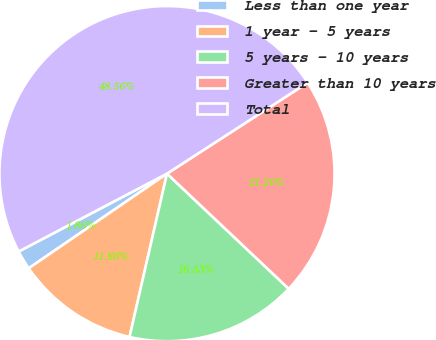Convert chart to OTSL. <chart><loc_0><loc_0><loc_500><loc_500><pie_chart><fcel>Less than one year<fcel>1 year - 5 years<fcel>5 years - 10 years<fcel>Greater than 10 years<fcel>Total<nl><fcel>1.86%<fcel>11.86%<fcel>16.53%<fcel>21.2%<fcel>48.56%<nl></chart> 